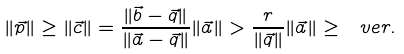Convert formula to latex. <formula><loc_0><loc_0><loc_500><loc_500>\| \vec { p } \| \geq \| \vec { c } \| = \frac { \| \vec { b } - \vec { q } \| } { \| \vec { a } - \vec { q } \| } \| \vec { a } \| > \frac { r } { \| \vec { q } \| } \| \vec { a } \| \geq \ v e r .</formula> 